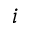Convert formula to latex. <formula><loc_0><loc_0><loc_500><loc_500>{ i }</formula> 